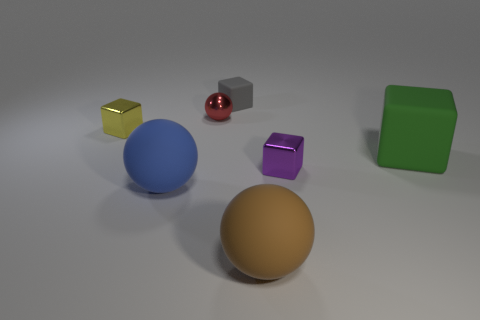Do the tiny rubber object and the large matte block have the same color? no 